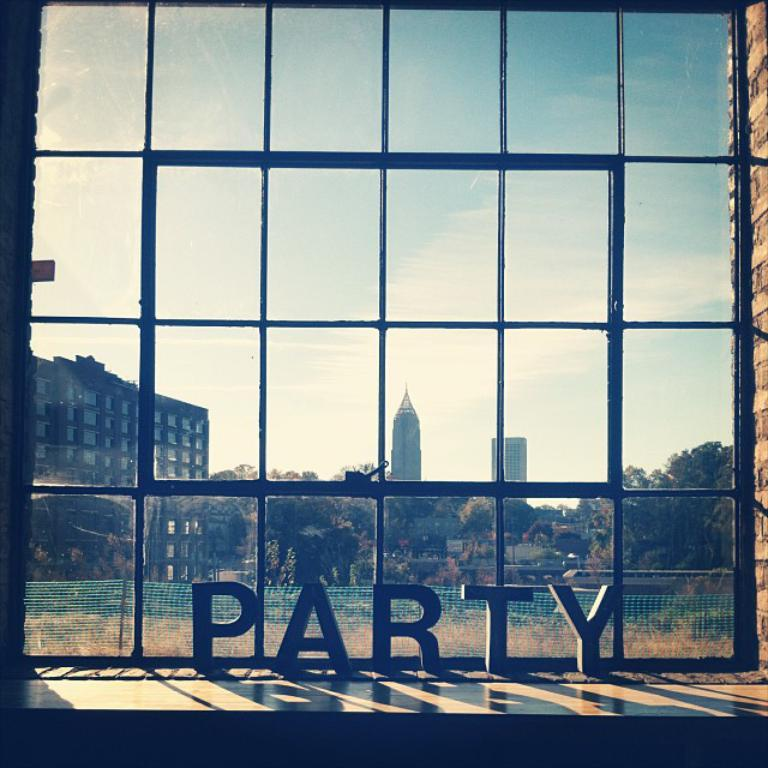What type of structure is present in the image? There is a glass window in the image. What is located in front of the glass window? There are letters visible in front of the glass window. What type of barrier is present on the grass in the image? There is a net fence on the grass in the image. What type of structures can be seen in the image? There are buildings in the image. What type of vegetation is present in the image? There are trees in the image. What part of the natural environment is visible in the image? The sky is visible in the image. What type of rings can be seen hanging from the trees in the image? There are no rings visible hanging from the trees in the image. What type of paper is used to create the letters in front of the glass window? There is no information about the type of paper used to create the letters in front of the glass window. 